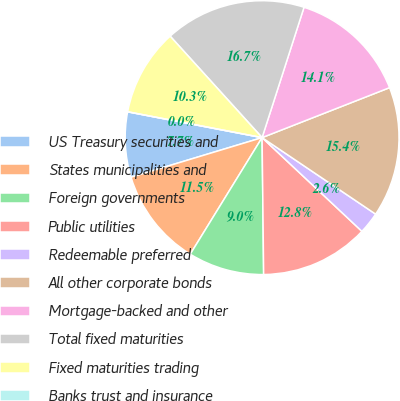<chart> <loc_0><loc_0><loc_500><loc_500><pie_chart><fcel>US Treasury securities and<fcel>States municipalities and<fcel>Foreign governments<fcel>Public utilities<fcel>Redeemable preferred<fcel>All other corporate bonds<fcel>Mortgage-backed and other<fcel>Total fixed maturities<fcel>Fixed maturities trading<fcel>Banks trust and insurance<nl><fcel>7.69%<fcel>11.54%<fcel>8.97%<fcel>12.82%<fcel>2.56%<fcel>15.38%<fcel>14.1%<fcel>16.67%<fcel>10.26%<fcel>0.0%<nl></chart> 